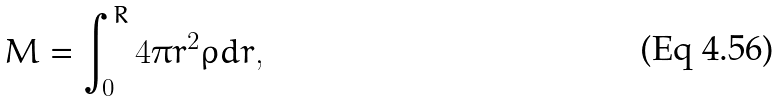<formula> <loc_0><loc_0><loc_500><loc_500>M = \int _ { 0 } ^ { R } 4 \pi r ^ { 2 } { \rho } d r ,</formula> 